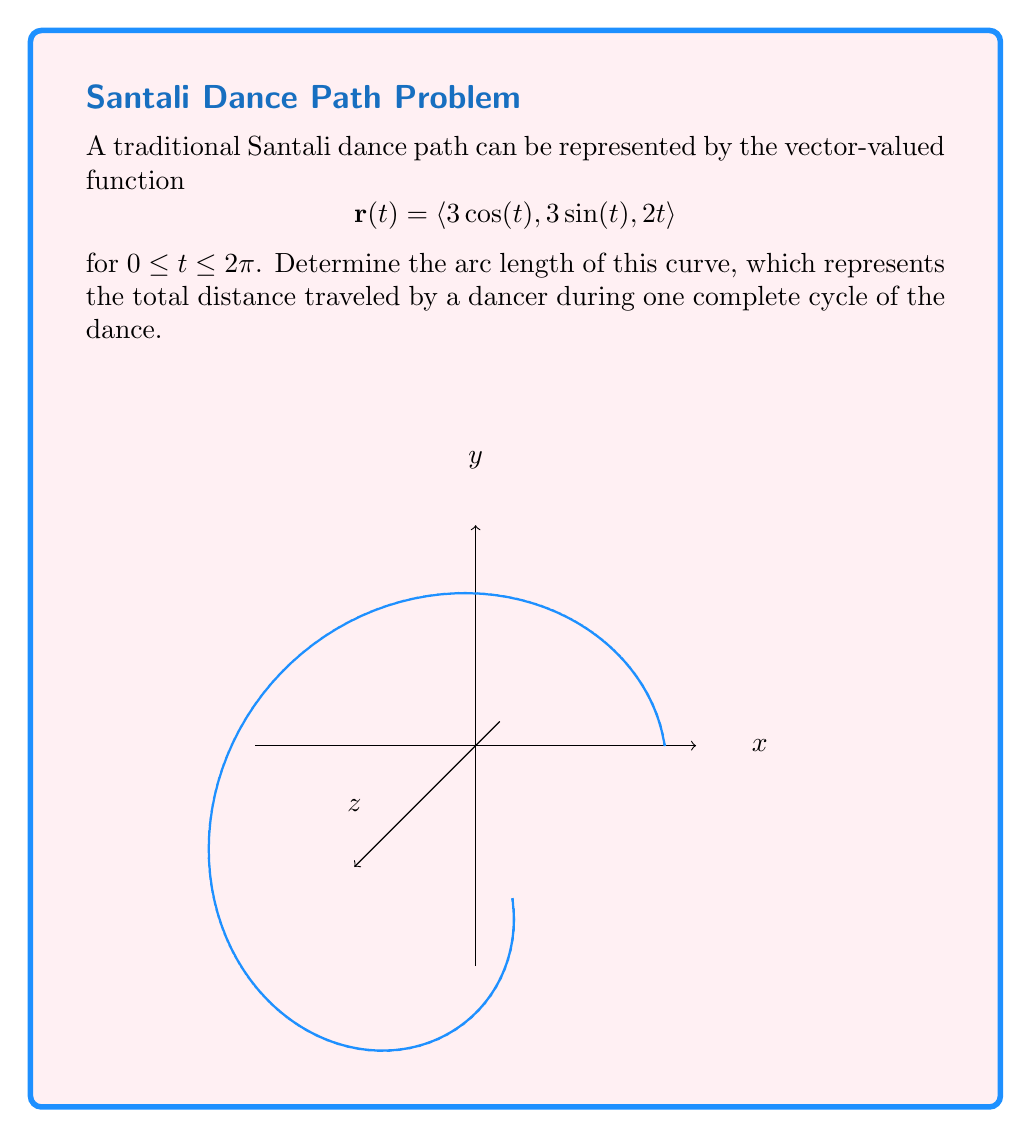Help me with this question. To find the arc length of a curve represented by a vector-valued function, we use the arc length formula:

$$L = \int_a^b \sqrt{\left(\frac{dx}{dt}\right)^2 + \left(\frac{dy}{dt}\right)^2 + \left(\frac{dz}{dt}\right)^2} dt$$

Step 1: Find the derivatives of x, y, and z with respect to t.
$\frac{dx}{dt} = -3\sin(t)$
$\frac{dy}{dt} = 3\cos(t)$
$\frac{dz}{dt} = 2$

Step 2: Square each derivative and add them together.
$$\left(\frac{dx}{dt}\right)^2 + \left(\frac{dy}{dt}\right)^2 + \left(\frac{dz}{dt}\right)^2 = (-3\sin(t))^2 + (3\cos(t))^2 + 2^2$$
$$= 9\sin^2(t) + 9\cos^2(t) + 4$$
$$= 9(\sin^2(t) + \cos^2(t)) + 4$$
$$= 9 + 4 = 13$$

Step 3: Take the square root of the result from Step 2.
$\sqrt{13}$

Step 4: Integrate the result from Step 3 over the given interval.
$$L = \int_0^{2\pi} \sqrt{13} dt$$

Step 5: Evaluate the integral.
$$L = \sqrt{13} \cdot t \bigg|_0^{2\pi} = 2\pi\sqrt{13}$$

Therefore, the arc length of the curve is $2\pi\sqrt{13}$.
Answer: $2\pi\sqrt{13}$ 